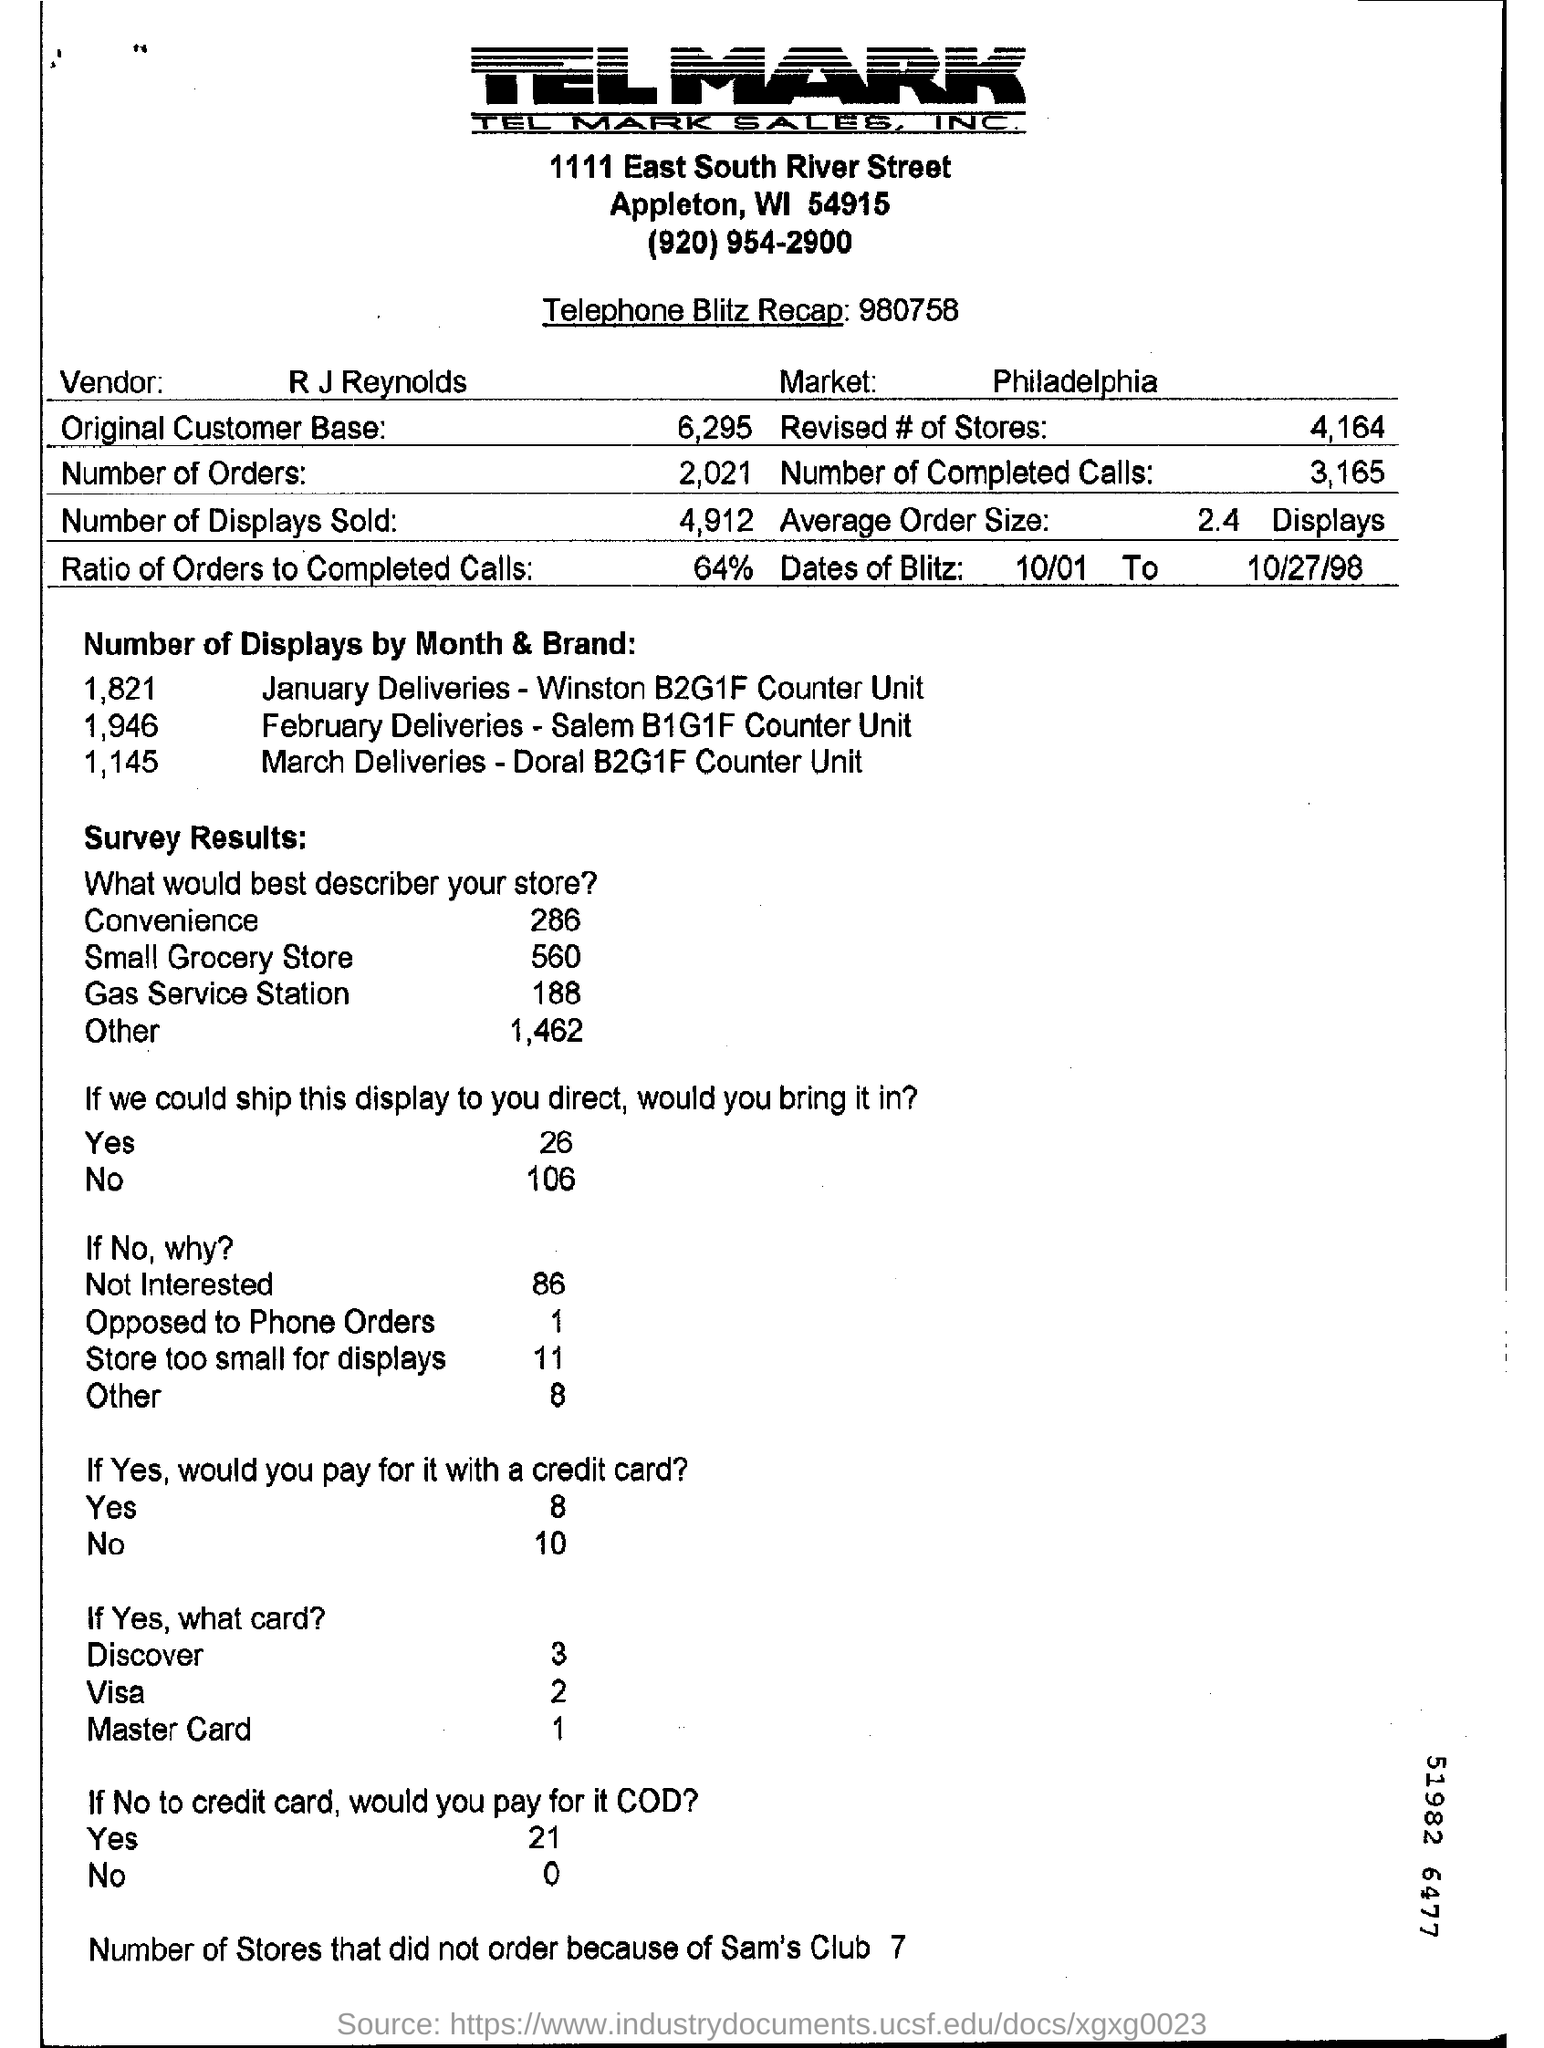What is the name of the vendor?
Offer a terse response. R J REYNOLDS. What is the ratio of orders to completed calls?
Ensure brevity in your answer.  64%. How many number of completed calls are mentioned in the form?
Your response must be concise. 3,165. How many number of revised stores are mentioned in the form?
Ensure brevity in your answer.  4,164. What is the average order size?
Your answer should be very brief. 2.4 displays. 